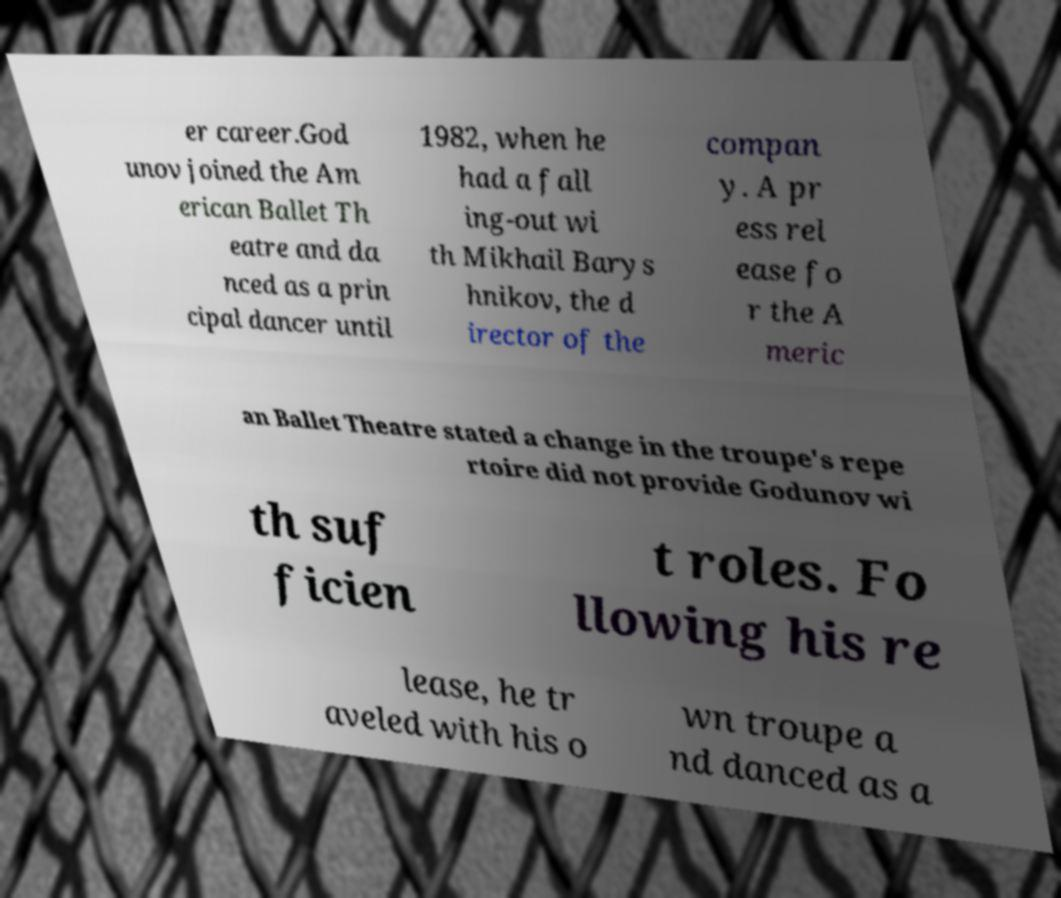Could you assist in decoding the text presented in this image and type it out clearly? er career.God unov joined the Am erican Ballet Th eatre and da nced as a prin cipal dancer until 1982, when he had a fall ing-out wi th Mikhail Barys hnikov, the d irector of the compan y. A pr ess rel ease fo r the A meric an Ballet Theatre stated a change in the troupe's repe rtoire did not provide Godunov wi th suf ficien t roles. Fo llowing his re lease, he tr aveled with his o wn troupe a nd danced as a 